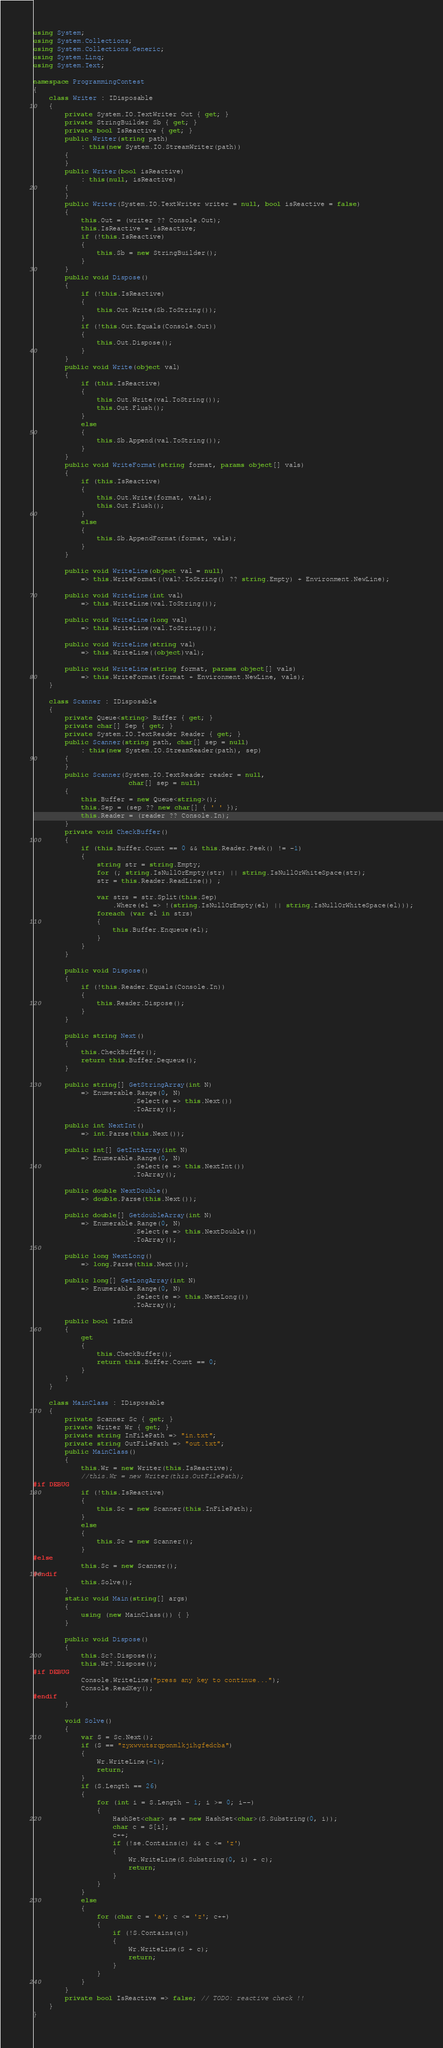Convert code to text. <code><loc_0><loc_0><loc_500><loc_500><_C#_>using System;
using System.Collections;
using System.Collections.Generic;
using System.Linq;
using System.Text;

namespace ProgrammingContest
{
    class Writer : IDisposable
    {
        private System.IO.TextWriter Out { get; }
        private StringBuilder Sb { get; }
        private bool IsReactive { get; }
        public Writer(string path)
            : this(new System.IO.StreamWriter(path))
        {
        }
        public Writer(bool isReactive)
            : this(null, isReactive)
        {
        }
        public Writer(System.IO.TextWriter writer = null, bool isReactive = false)
        {
            this.Out = (writer ?? Console.Out);
            this.IsReactive = isReactive;
            if (!this.IsReactive)
            {
                this.Sb = new StringBuilder();
            }
        }
        public void Dispose()
        {
            if (!this.IsReactive)
            {
                this.Out.Write(Sb.ToString());
            }
            if (!this.Out.Equals(Console.Out))
            {
                this.Out.Dispose();
            }
        }
        public void Write(object val)
        {
            if (this.IsReactive)
            {
                this.Out.Write(val.ToString());
                this.Out.Flush();
            }
            else
            {
                this.Sb.Append(val.ToString());
            }
        }
        public void WriteFormat(string format, params object[] vals)
        {
            if (this.IsReactive)
            {
                this.Out.Write(format, vals);
                this.Out.Flush();
            }
            else
            {
                this.Sb.AppendFormat(format, vals);
            }
        }

        public void WriteLine(object val = null)
            => this.WriteFormat((val?.ToString() ?? string.Empty) + Environment.NewLine);

        public void WriteLine(int val)
            => this.WriteLine(val.ToString());

        public void WriteLine(long val)
            => this.WriteLine(val.ToString());

        public void WriteLine(string val)
            => this.WriteLine((object)val);

        public void WriteLine(string format, params object[] vals)
            => this.WriteFormat(format + Environment.NewLine, vals);
    }

    class Scanner : IDisposable
    {
        private Queue<string> Buffer { get; }
        private char[] Sep { get; }
        private System.IO.TextReader Reader { get; }
        public Scanner(string path, char[] sep = null)
            : this(new System.IO.StreamReader(path), sep)
        {
        }
        public Scanner(System.IO.TextReader reader = null,
                        char[] sep = null)
        {
            this.Buffer = new Queue<string>();
            this.Sep = (sep ?? new char[] { ' ' });
            this.Reader = (reader ?? Console.In);
        }
        private void CheckBuffer()
        {
            if (this.Buffer.Count == 0 && this.Reader.Peek() != -1)
            {
                string str = string.Empty;
                for (; string.IsNullOrEmpty(str) || string.IsNullOrWhiteSpace(str);
                str = this.Reader.ReadLine()) ;

                var strs = str.Split(this.Sep)
                    .Where(el => !(string.IsNullOrEmpty(el) || string.IsNullOrWhiteSpace(el)));
                foreach (var el in strs)
                {
                    this.Buffer.Enqueue(el);
                }
            }
        }

        public void Dispose()
        {
            if (!this.Reader.Equals(Console.In))
            {
                this.Reader.Dispose();
            }
        }

        public string Next()
        {
            this.CheckBuffer();
            return this.Buffer.Dequeue();
        }

        public string[] GetStringArray(int N)
            => Enumerable.Range(0, N)
                         .Select(e => this.Next())
                         .ToArray();

        public int NextInt()
            => int.Parse(this.Next());

        public int[] GetIntArray(int N)
            => Enumerable.Range(0, N)
                         .Select(e => this.NextInt())
                         .ToArray();

        public double NextDouble()
            => double.Parse(this.Next());

        public double[] GetdoubleArray(int N)
            => Enumerable.Range(0, N)
                         .Select(e => this.NextDouble())
                         .ToArray();

        public long NextLong()
            => long.Parse(this.Next());

        public long[] GetLongArray(int N)
            => Enumerable.Range(0, N)
                         .Select(e => this.NextLong())
                         .ToArray();

        public bool IsEnd
        {
            get
            {
                this.CheckBuffer();
                return this.Buffer.Count == 0;
            }
        }
    }

    class MainClass : IDisposable
    {
        private Scanner Sc { get; }
        private Writer Wr { get; }
        private string InFilePath => "in.txt";
        private string OutFilePath => "out.txt";
        public MainClass()
        {
            this.Wr = new Writer(this.IsReactive);
            //this.Wr = new Writer(this.OutFilePath);
#if DEBUG
            if (!this.IsReactive)
            {
                this.Sc = new Scanner(this.InFilePath);
            }
            else
            {
                this.Sc = new Scanner();
            }
#else
            this.Sc = new Scanner();
#endif
            this.Solve();
        }
        static void Main(string[] args)
        {
            using (new MainClass()) { }
        }

        public void Dispose()
        {
            this.Sc?.Dispose();
            this.Wr?.Dispose();
#if DEBUG
            Console.WriteLine("press any key to continue...");
            Console.ReadKey();
#endif
        }

        void Solve()
        {
            var S = Sc.Next();
            if (S == "zyxwvutsrqponmlkjihgfedcba")
            {
                Wr.WriteLine(-1);
                return;
            }
            if (S.Length == 26)
            {
                for (int i = S.Length - 1; i >= 0; i--)
                {
                    HashSet<char> se = new HashSet<char>(S.Substring(0, i));
                    char c = S[i];
                    c++;
                    if (!se.Contains(c) && c <= 'z')
                    {
                        Wr.WriteLine(S.Substring(0, i) + c);
                        return;
                    }
                }
            }
            else
            {
                for (char c = 'a'; c <= 'z'; c++)
                {
                    if (!S.Contains(c))
                    {
                        Wr.WriteLine(S + c);
                        return;
                    }
                }
            }
        }
        private bool IsReactive => false; // TODO: reactive check !!
    }
}
</code> 